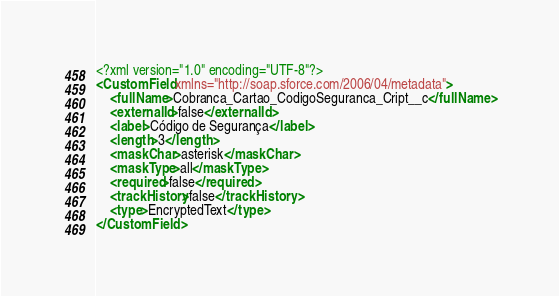<code> <loc_0><loc_0><loc_500><loc_500><_XML_><?xml version="1.0" encoding="UTF-8"?>
<CustomField xmlns="http://soap.sforce.com/2006/04/metadata">
    <fullName>Cobranca_Cartao_CodigoSeguranca_Cript__c</fullName>
    <externalId>false</externalId>
    <label>Código de Segurança</label>
    <length>3</length>
    <maskChar>asterisk</maskChar>
    <maskType>all</maskType>
    <required>false</required>
    <trackHistory>false</trackHistory>
    <type>EncryptedText</type>
</CustomField>
</code> 